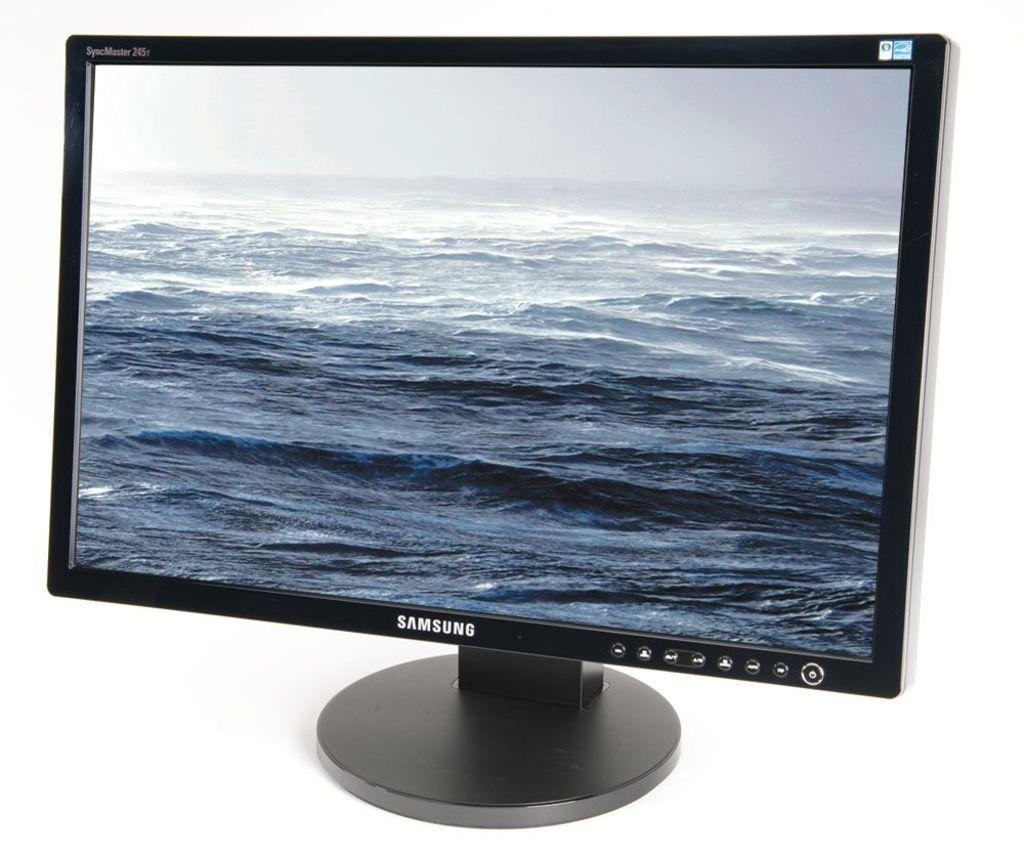<image>
Provide a brief description of the given image. A Samsung SyncMaster features ocean waves on its display. 